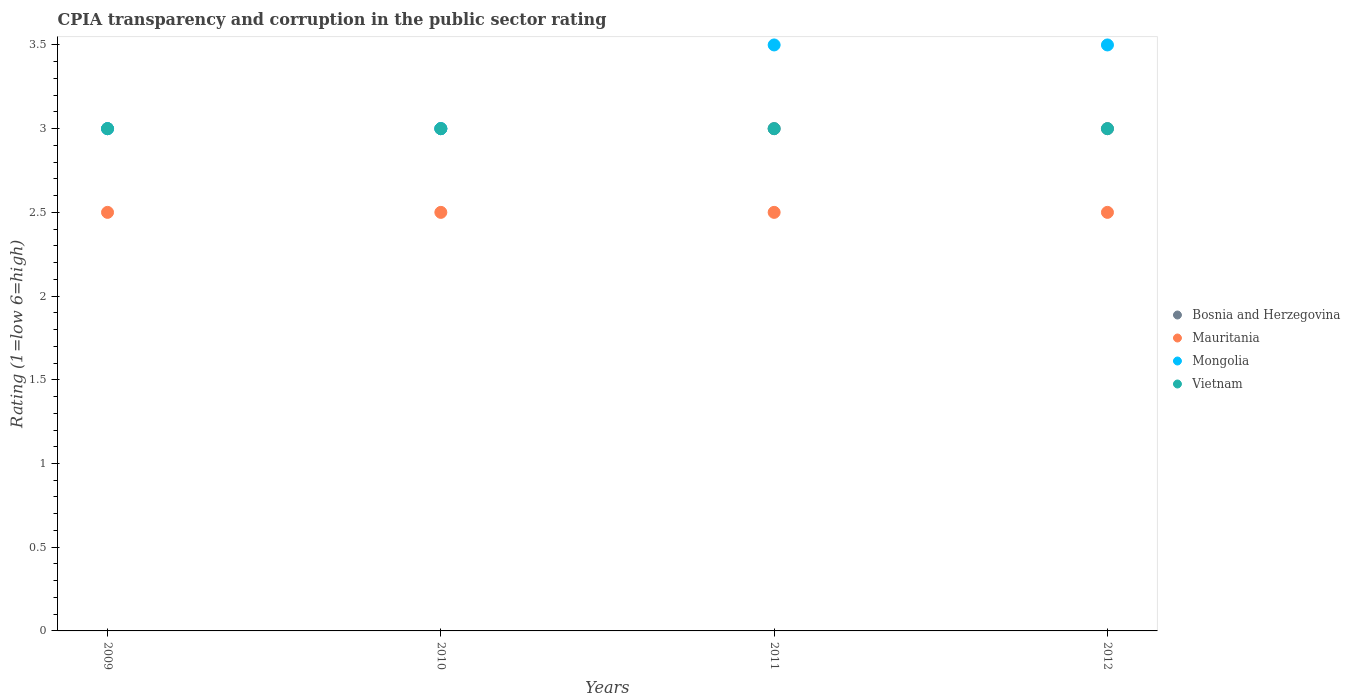What is the CPIA rating in Bosnia and Herzegovina in 2009?
Give a very brief answer. 3. Across all years, what is the minimum CPIA rating in Bosnia and Herzegovina?
Your response must be concise. 3. What is the total CPIA rating in Vietnam in the graph?
Provide a short and direct response. 12. What is the difference between the CPIA rating in Mongolia in 2011 and the CPIA rating in Bosnia and Herzegovina in 2010?
Provide a succinct answer. 0.5. What is the average CPIA rating in Mauritania per year?
Offer a very short reply. 2.5. In the year 2012, what is the difference between the CPIA rating in Vietnam and CPIA rating in Mauritania?
Your answer should be compact. 0.5. In how many years, is the CPIA rating in Bosnia and Herzegovina greater than 3.3?
Offer a very short reply. 0. What is the ratio of the CPIA rating in Mongolia in 2011 to that in 2012?
Give a very brief answer. 1. Is the CPIA rating in Bosnia and Herzegovina in 2009 less than that in 2011?
Your answer should be compact. No. What is the difference between the highest and the second highest CPIA rating in Vietnam?
Make the answer very short. 0. What is the difference between the highest and the lowest CPIA rating in Bosnia and Herzegovina?
Your answer should be very brief. 0. Is the sum of the CPIA rating in Bosnia and Herzegovina in 2009 and 2011 greater than the maximum CPIA rating in Mauritania across all years?
Provide a short and direct response. Yes. Is the CPIA rating in Vietnam strictly greater than the CPIA rating in Mauritania over the years?
Ensure brevity in your answer.  Yes. How many years are there in the graph?
Your answer should be very brief. 4. Are the values on the major ticks of Y-axis written in scientific E-notation?
Offer a terse response. No. Does the graph contain any zero values?
Your answer should be compact. No. Does the graph contain grids?
Offer a terse response. No. How many legend labels are there?
Give a very brief answer. 4. What is the title of the graph?
Your answer should be compact. CPIA transparency and corruption in the public sector rating. Does "New Caledonia" appear as one of the legend labels in the graph?
Ensure brevity in your answer.  No. What is the label or title of the Y-axis?
Your response must be concise. Rating (1=low 6=high). What is the Rating (1=low 6=high) in Mongolia in 2010?
Provide a short and direct response. 3. What is the Rating (1=low 6=high) of Vietnam in 2010?
Ensure brevity in your answer.  3. What is the Rating (1=low 6=high) in Bosnia and Herzegovina in 2011?
Offer a terse response. 3. What is the Rating (1=low 6=high) in Vietnam in 2011?
Offer a very short reply. 3. What is the Rating (1=low 6=high) in Mauritania in 2012?
Offer a very short reply. 2.5. Across all years, what is the maximum Rating (1=low 6=high) of Bosnia and Herzegovina?
Ensure brevity in your answer.  3. Across all years, what is the maximum Rating (1=low 6=high) of Vietnam?
Ensure brevity in your answer.  3. Across all years, what is the minimum Rating (1=low 6=high) in Bosnia and Herzegovina?
Give a very brief answer. 3. Across all years, what is the minimum Rating (1=low 6=high) of Mauritania?
Make the answer very short. 2.5. Across all years, what is the minimum Rating (1=low 6=high) in Mongolia?
Your answer should be very brief. 3. What is the total Rating (1=low 6=high) of Bosnia and Herzegovina in the graph?
Your answer should be very brief. 12. What is the total Rating (1=low 6=high) of Mauritania in the graph?
Your answer should be compact. 10. What is the difference between the Rating (1=low 6=high) in Vietnam in 2009 and that in 2010?
Make the answer very short. 0. What is the difference between the Rating (1=low 6=high) in Mauritania in 2009 and that in 2011?
Your answer should be compact. 0. What is the difference between the Rating (1=low 6=high) in Mongolia in 2009 and that in 2011?
Offer a terse response. -0.5. What is the difference between the Rating (1=low 6=high) in Vietnam in 2009 and that in 2011?
Give a very brief answer. 0. What is the difference between the Rating (1=low 6=high) in Bosnia and Herzegovina in 2009 and that in 2012?
Offer a very short reply. 0. What is the difference between the Rating (1=low 6=high) in Mauritania in 2009 and that in 2012?
Keep it short and to the point. 0. What is the difference between the Rating (1=low 6=high) of Vietnam in 2009 and that in 2012?
Offer a terse response. 0. What is the difference between the Rating (1=low 6=high) in Vietnam in 2010 and that in 2011?
Offer a terse response. 0. What is the difference between the Rating (1=low 6=high) of Bosnia and Herzegovina in 2010 and that in 2012?
Offer a terse response. 0. What is the difference between the Rating (1=low 6=high) in Mauritania in 2010 and that in 2012?
Keep it short and to the point. 0. What is the difference between the Rating (1=low 6=high) in Vietnam in 2010 and that in 2012?
Your answer should be very brief. 0. What is the difference between the Rating (1=low 6=high) in Mongolia in 2011 and that in 2012?
Ensure brevity in your answer.  0. What is the difference between the Rating (1=low 6=high) in Vietnam in 2011 and that in 2012?
Your answer should be very brief. 0. What is the difference between the Rating (1=low 6=high) in Bosnia and Herzegovina in 2009 and the Rating (1=low 6=high) in Vietnam in 2010?
Offer a terse response. 0. What is the difference between the Rating (1=low 6=high) in Mongolia in 2009 and the Rating (1=low 6=high) in Vietnam in 2010?
Make the answer very short. 0. What is the difference between the Rating (1=low 6=high) in Bosnia and Herzegovina in 2009 and the Rating (1=low 6=high) in Mauritania in 2011?
Your answer should be compact. 0.5. What is the difference between the Rating (1=low 6=high) in Bosnia and Herzegovina in 2009 and the Rating (1=low 6=high) in Vietnam in 2011?
Offer a very short reply. 0. What is the difference between the Rating (1=low 6=high) of Mauritania in 2009 and the Rating (1=low 6=high) of Mongolia in 2011?
Your answer should be compact. -1. What is the difference between the Rating (1=low 6=high) in Bosnia and Herzegovina in 2009 and the Rating (1=low 6=high) in Mongolia in 2012?
Ensure brevity in your answer.  -0.5. What is the difference between the Rating (1=low 6=high) in Bosnia and Herzegovina in 2010 and the Rating (1=low 6=high) in Mauritania in 2011?
Provide a succinct answer. 0.5. What is the difference between the Rating (1=low 6=high) in Bosnia and Herzegovina in 2010 and the Rating (1=low 6=high) in Mongolia in 2011?
Make the answer very short. -0.5. What is the difference between the Rating (1=low 6=high) of Mauritania in 2010 and the Rating (1=low 6=high) of Mongolia in 2011?
Keep it short and to the point. -1. What is the difference between the Rating (1=low 6=high) in Bosnia and Herzegovina in 2010 and the Rating (1=low 6=high) in Mongolia in 2012?
Your answer should be very brief. -0.5. What is the difference between the Rating (1=low 6=high) in Mauritania in 2010 and the Rating (1=low 6=high) in Vietnam in 2012?
Provide a succinct answer. -0.5. What is the difference between the Rating (1=low 6=high) of Bosnia and Herzegovina in 2011 and the Rating (1=low 6=high) of Mongolia in 2012?
Keep it short and to the point. -0.5. What is the difference between the Rating (1=low 6=high) of Mauritania in 2011 and the Rating (1=low 6=high) of Mongolia in 2012?
Provide a succinct answer. -1. What is the average Rating (1=low 6=high) in Mauritania per year?
Make the answer very short. 2.5. What is the average Rating (1=low 6=high) in Vietnam per year?
Provide a succinct answer. 3. In the year 2009, what is the difference between the Rating (1=low 6=high) in Bosnia and Herzegovina and Rating (1=low 6=high) in Mauritania?
Ensure brevity in your answer.  0.5. In the year 2009, what is the difference between the Rating (1=low 6=high) of Mongolia and Rating (1=low 6=high) of Vietnam?
Provide a short and direct response. 0. In the year 2010, what is the difference between the Rating (1=low 6=high) of Mongolia and Rating (1=low 6=high) of Vietnam?
Your answer should be compact. 0. In the year 2011, what is the difference between the Rating (1=low 6=high) of Mauritania and Rating (1=low 6=high) of Vietnam?
Offer a very short reply. -0.5. In the year 2012, what is the difference between the Rating (1=low 6=high) of Bosnia and Herzegovina and Rating (1=low 6=high) of Mauritania?
Your answer should be compact. 0.5. In the year 2012, what is the difference between the Rating (1=low 6=high) in Bosnia and Herzegovina and Rating (1=low 6=high) in Mongolia?
Provide a succinct answer. -0.5. In the year 2012, what is the difference between the Rating (1=low 6=high) of Bosnia and Herzegovina and Rating (1=low 6=high) of Vietnam?
Give a very brief answer. 0. In the year 2012, what is the difference between the Rating (1=low 6=high) of Mauritania and Rating (1=low 6=high) of Mongolia?
Keep it short and to the point. -1. What is the ratio of the Rating (1=low 6=high) in Bosnia and Herzegovina in 2009 to that in 2010?
Give a very brief answer. 1. What is the ratio of the Rating (1=low 6=high) in Bosnia and Herzegovina in 2009 to that in 2011?
Ensure brevity in your answer.  1. What is the ratio of the Rating (1=low 6=high) in Mauritania in 2009 to that in 2011?
Keep it short and to the point. 1. What is the ratio of the Rating (1=low 6=high) in Mongolia in 2009 to that in 2011?
Keep it short and to the point. 0.86. What is the ratio of the Rating (1=low 6=high) of Vietnam in 2009 to that in 2011?
Offer a very short reply. 1. What is the ratio of the Rating (1=low 6=high) in Mauritania in 2009 to that in 2012?
Ensure brevity in your answer.  1. What is the ratio of the Rating (1=low 6=high) in Vietnam in 2009 to that in 2012?
Provide a short and direct response. 1. What is the ratio of the Rating (1=low 6=high) of Mauritania in 2010 to that in 2011?
Offer a terse response. 1. What is the ratio of the Rating (1=low 6=high) in Mongolia in 2010 to that in 2011?
Offer a very short reply. 0.86. What is the ratio of the Rating (1=low 6=high) in Vietnam in 2010 to that in 2011?
Provide a succinct answer. 1. What is the ratio of the Rating (1=low 6=high) in Bosnia and Herzegovina in 2010 to that in 2012?
Your answer should be very brief. 1. What is the ratio of the Rating (1=low 6=high) in Mauritania in 2010 to that in 2012?
Give a very brief answer. 1. What is the ratio of the Rating (1=low 6=high) in Mongolia in 2010 to that in 2012?
Keep it short and to the point. 0.86. What is the ratio of the Rating (1=low 6=high) in Bosnia and Herzegovina in 2011 to that in 2012?
Offer a very short reply. 1. What is the difference between the highest and the second highest Rating (1=low 6=high) in Bosnia and Herzegovina?
Offer a very short reply. 0. What is the difference between the highest and the lowest Rating (1=low 6=high) of Mongolia?
Ensure brevity in your answer.  0.5. What is the difference between the highest and the lowest Rating (1=low 6=high) of Vietnam?
Keep it short and to the point. 0. 